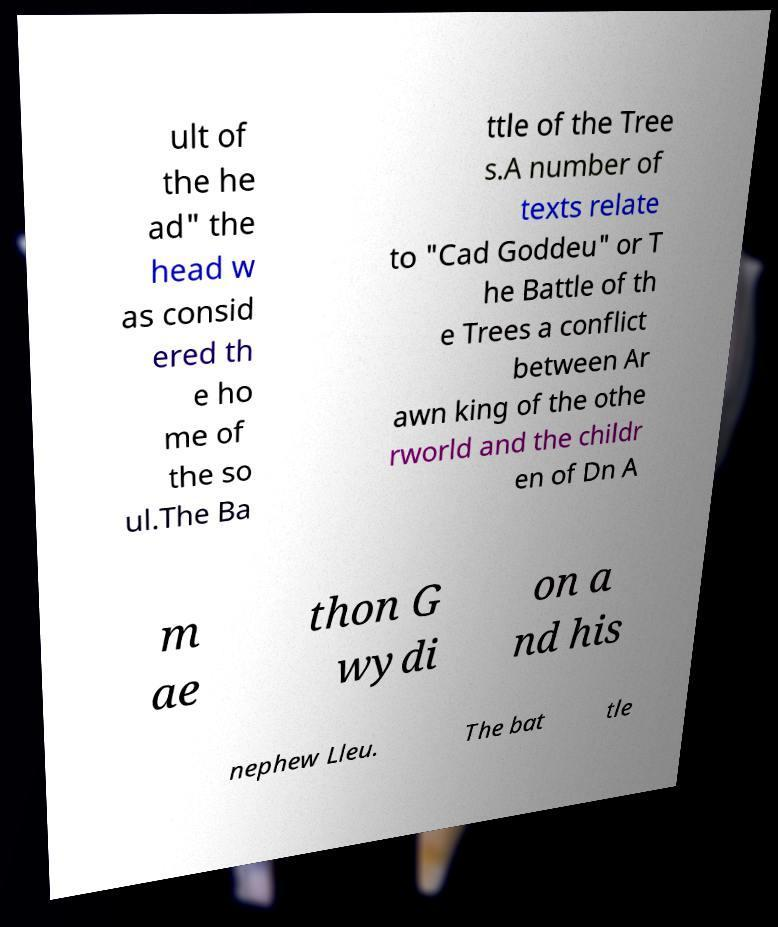I need the written content from this picture converted into text. Can you do that? ult of the he ad" the head w as consid ered th e ho me of the so ul.The Ba ttle of the Tree s.A number of texts relate to "Cad Goddeu" or T he Battle of th e Trees a conflict between Ar awn king of the othe rworld and the childr en of Dn A m ae thon G wydi on a nd his nephew Lleu. The bat tle 